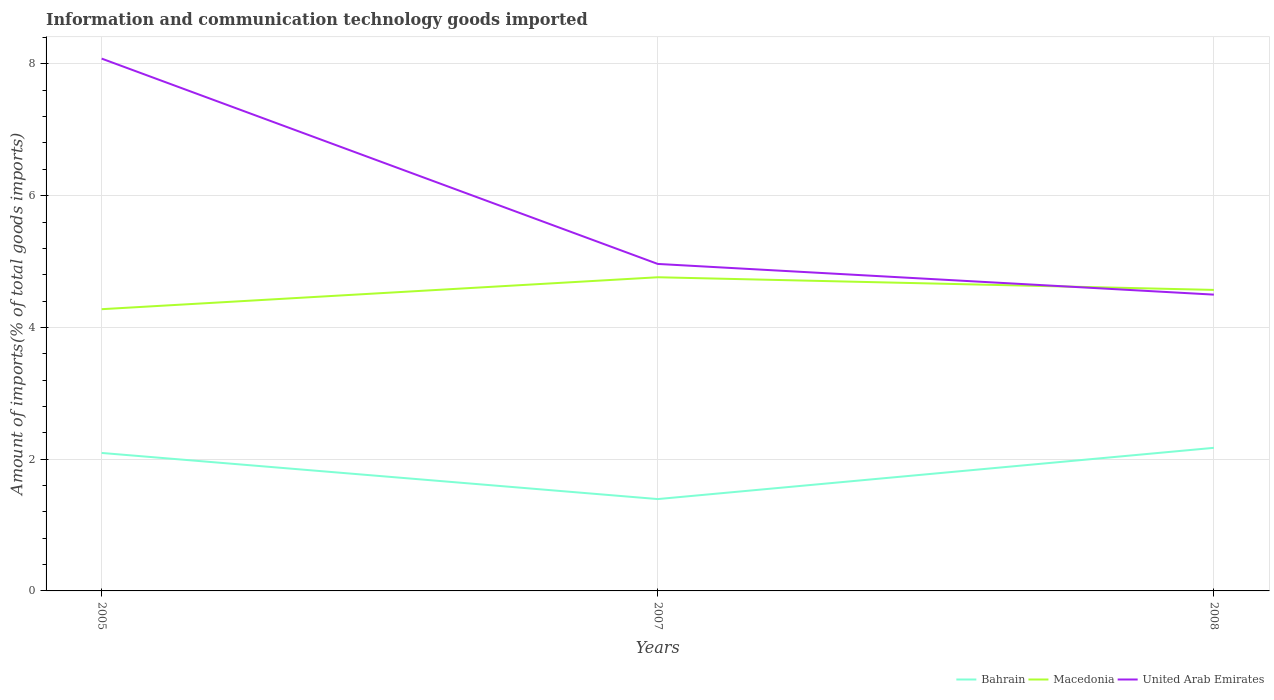How many different coloured lines are there?
Provide a short and direct response. 3. Across all years, what is the maximum amount of goods imported in Macedonia?
Ensure brevity in your answer.  4.28. What is the total amount of goods imported in United Arab Emirates in the graph?
Give a very brief answer. 3.12. What is the difference between the highest and the second highest amount of goods imported in Macedonia?
Offer a very short reply. 0.48. What is the difference between the highest and the lowest amount of goods imported in United Arab Emirates?
Provide a succinct answer. 1. How many years are there in the graph?
Your response must be concise. 3. What is the difference between two consecutive major ticks on the Y-axis?
Provide a short and direct response. 2. How are the legend labels stacked?
Offer a terse response. Horizontal. What is the title of the graph?
Give a very brief answer. Information and communication technology goods imported. Does "Russian Federation" appear as one of the legend labels in the graph?
Your answer should be very brief. No. What is the label or title of the X-axis?
Provide a succinct answer. Years. What is the label or title of the Y-axis?
Your answer should be compact. Amount of imports(% of total goods imports). What is the Amount of imports(% of total goods imports) in Bahrain in 2005?
Your response must be concise. 2.09. What is the Amount of imports(% of total goods imports) of Macedonia in 2005?
Your response must be concise. 4.28. What is the Amount of imports(% of total goods imports) in United Arab Emirates in 2005?
Your response must be concise. 8.08. What is the Amount of imports(% of total goods imports) of Bahrain in 2007?
Provide a short and direct response. 1.39. What is the Amount of imports(% of total goods imports) of Macedonia in 2007?
Give a very brief answer. 4.76. What is the Amount of imports(% of total goods imports) in United Arab Emirates in 2007?
Your answer should be very brief. 4.96. What is the Amount of imports(% of total goods imports) in Bahrain in 2008?
Make the answer very short. 2.17. What is the Amount of imports(% of total goods imports) of Macedonia in 2008?
Make the answer very short. 4.57. What is the Amount of imports(% of total goods imports) of United Arab Emirates in 2008?
Provide a short and direct response. 4.5. Across all years, what is the maximum Amount of imports(% of total goods imports) in Bahrain?
Provide a succinct answer. 2.17. Across all years, what is the maximum Amount of imports(% of total goods imports) of Macedonia?
Ensure brevity in your answer.  4.76. Across all years, what is the maximum Amount of imports(% of total goods imports) in United Arab Emirates?
Give a very brief answer. 8.08. Across all years, what is the minimum Amount of imports(% of total goods imports) of Bahrain?
Your response must be concise. 1.39. Across all years, what is the minimum Amount of imports(% of total goods imports) of Macedonia?
Make the answer very short. 4.28. Across all years, what is the minimum Amount of imports(% of total goods imports) of United Arab Emirates?
Provide a short and direct response. 4.5. What is the total Amount of imports(% of total goods imports) in Bahrain in the graph?
Provide a succinct answer. 5.66. What is the total Amount of imports(% of total goods imports) in Macedonia in the graph?
Give a very brief answer. 13.61. What is the total Amount of imports(% of total goods imports) in United Arab Emirates in the graph?
Keep it short and to the point. 17.54. What is the difference between the Amount of imports(% of total goods imports) in Bahrain in 2005 and that in 2007?
Offer a terse response. 0.7. What is the difference between the Amount of imports(% of total goods imports) of Macedonia in 2005 and that in 2007?
Your response must be concise. -0.48. What is the difference between the Amount of imports(% of total goods imports) in United Arab Emirates in 2005 and that in 2007?
Your answer should be very brief. 3.12. What is the difference between the Amount of imports(% of total goods imports) of Bahrain in 2005 and that in 2008?
Your answer should be very brief. -0.08. What is the difference between the Amount of imports(% of total goods imports) in Macedonia in 2005 and that in 2008?
Offer a terse response. -0.29. What is the difference between the Amount of imports(% of total goods imports) of United Arab Emirates in 2005 and that in 2008?
Ensure brevity in your answer.  3.58. What is the difference between the Amount of imports(% of total goods imports) in Bahrain in 2007 and that in 2008?
Keep it short and to the point. -0.78. What is the difference between the Amount of imports(% of total goods imports) of Macedonia in 2007 and that in 2008?
Your answer should be compact. 0.19. What is the difference between the Amount of imports(% of total goods imports) of United Arab Emirates in 2007 and that in 2008?
Keep it short and to the point. 0.47. What is the difference between the Amount of imports(% of total goods imports) of Bahrain in 2005 and the Amount of imports(% of total goods imports) of Macedonia in 2007?
Ensure brevity in your answer.  -2.67. What is the difference between the Amount of imports(% of total goods imports) of Bahrain in 2005 and the Amount of imports(% of total goods imports) of United Arab Emirates in 2007?
Keep it short and to the point. -2.87. What is the difference between the Amount of imports(% of total goods imports) in Macedonia in 2005 and the Amount of imports(% of total goods imports) in United Arab Emirates in 2007?
Offer a very short reply. -0.69. What is the difference between the Amount of imports(% of total goods imports) of Bahrain in 2005 and the Amount of imports(% of total goods imports) of Macedonia in 2008?
Your answer should be very brief. -2.48. What is the difference between the Amount of imports(% of total goods imports) in Bahrain in 2005 and the Amount of imports(% of total goods imports) in United Arab Emirates in 2008?
Offer a very short reply. -2.4. What is the difference between the Amount of imports(% of total goods imports) of Macedonia in 2005 and the Amount of imports(% of total goods imports) of United Arab Emirates in 2008?
Your answer should be very brief. -0.22. What is the difference between the Amount of imports(% of total goods imports) of Bahrain in 2007 and the Amount of imports(% of total goods imports) of Macedonia in 2008?
Offer a very short reply. -3.18. What is the difference between the Amount of imports(% of total goods imports) of Bahrain in 2007 and the Amount of imports(% of total goods imports) of United Arab Emirates in 2008?
Offer a very short reply. -3.1. What is the difference between the Amount of imports(% of total goods imports) of Macedonia in 2007 and the Amount of imports(% of total goods imports) of United Arab Emirates in 2008?
Ensure brevity in your answer.  0.26. What is the average Amount of imports(% of total goods imports) in Bahrain per year?
Make the answer very short. 1.89. What is the average Amount of imports(% of total goods imports) in Macedonia per year?
Keep it short and to the point. 4.54. What is the average Amount of imports(% of total goods imports) of United Arab Emirates per year?
Make the answer very short. 5.85. In the year 2005, what is the difference between the Amount of imports(% of total goods imports) of Bahrain and Amount of imports(% of total goods imports) of Macedonia?
Your answer should be very brief. -2.18. In the year 2005, what is the difference between the Amount of imports(% of total goods imports) in Bahrain and Amount of imports(% of total goods imports) in United Arab Emirates?
Offer a terse response. -5.99. In the year 2005, what is the difference between the Amount of imports(% of total goods imports) in Macedonia and Amount of imports(% of total goods imports) in United Arab Emirates?
Your answer should be compact. -3.8. In the year 2007, what is the difference between the Amount of imports(% of total goods imports) in Bahrain and Amount of imports(% of total goods imports) in Macedonia?
Keep it short and to the point. -3.37. In the year 2007, what is the difference between the Amount of imports(% of total goods imports) of Bahrain and Amount of imports(% of total goods imports) of United Arab Emirates?
Your answer should be compact. -3.57. In the year 2007, what is the difference between the Amount of imports(% of total goods imports) in Macedonia and Amount of imports(% of total goods imports) in United Arab Emirates?
Keep it short and to the point. -0.2. In the year 2008, what is the difference between the Amount of imports(% of total goods imports) of Bahrain and Amount of imports(% of total goods imports) of Macedonia?
Your answer should be very brief. -2.4. In the year 2008, what is the difference between the Amount of imports(% of total goods imports) of Bahrain and Amount of imports(% of total goods imports) of United Arab Emirates?
Your answer should be compact. -2.33. In the year 2008, what is the difference between the Amount of imports(% of total goods imports) of Macedonia and Amount of imports(% of total goods imports) of United Arab Emirates?
Provide a short and direct response. 0.07. What is the ratio of the Amount of imports(% of total goods imports) in Bahrain in 2005 to that in 2007?
Give a very brief answer. 1.5. What is the ratio of the Amount of imports(% of total goods imports) of Macedonia in 2005 to that in 2007?
Provide a short and direct response. 0.9. What is the ratio of the Amount of imports(% of total goods imports) of United Arab Emirates in 2005 to that in 2007?
Keep it short and to the point. 1.63. What is the ratio of the Amount of imports(% of total goods imports) of Bahrain in 2005 to that in 2008?
Give a very brief answer. 0.96. What is the ratio of the Amount of imports(% of total goods imports) of Macedonia in 2005 to that in 2008?
Offer a terse response. 0.94. What is the ratio of the Amount of imports(% of total goods imports) of United Arab Emirates in 2005 to that in 2008?
Your response must be concise. 1.8. What is the ratio of the Amount of imports(% of total goods imports) in Bahrain in 2007 to that in 2008?
Ensure brevity in your answer.  0.64. What is the ratio of the Amount of imports(% of total goods imports) in Macedonia in 2007 to that in 2008?
Your answer should be compact. 1.04. What is the ratio of the Amount of imports(% of total goods imports) of United Arab Emirates in 2007 to that in 2008?
Ensure brevity in your answer.  1.1. What is the difference between the highest and the second highest Amount of imports(% of total goods imports) of Bahrain?
Provide a short and direct response. 0.08. What is the difference between the highest and the second highest Amount of imports(% of total goods imports) of Macedonia?
Your answer should be very brief. 0.19. What is the difference between the highest and the second highest Amount of imports(% of total goods imports) in United Arab Emirates?
Your answer should be very brief. 3.12. What is the difference between the highest and the lowest Amount of imports(% of total goods imports) in Macedonia?
Offer a very short reply. 0.48. What is the difference between the highest and the lowest Amount of imports(% of total goods imports) in United Arab Emirates?
Your answer should be compact. 3.58. 